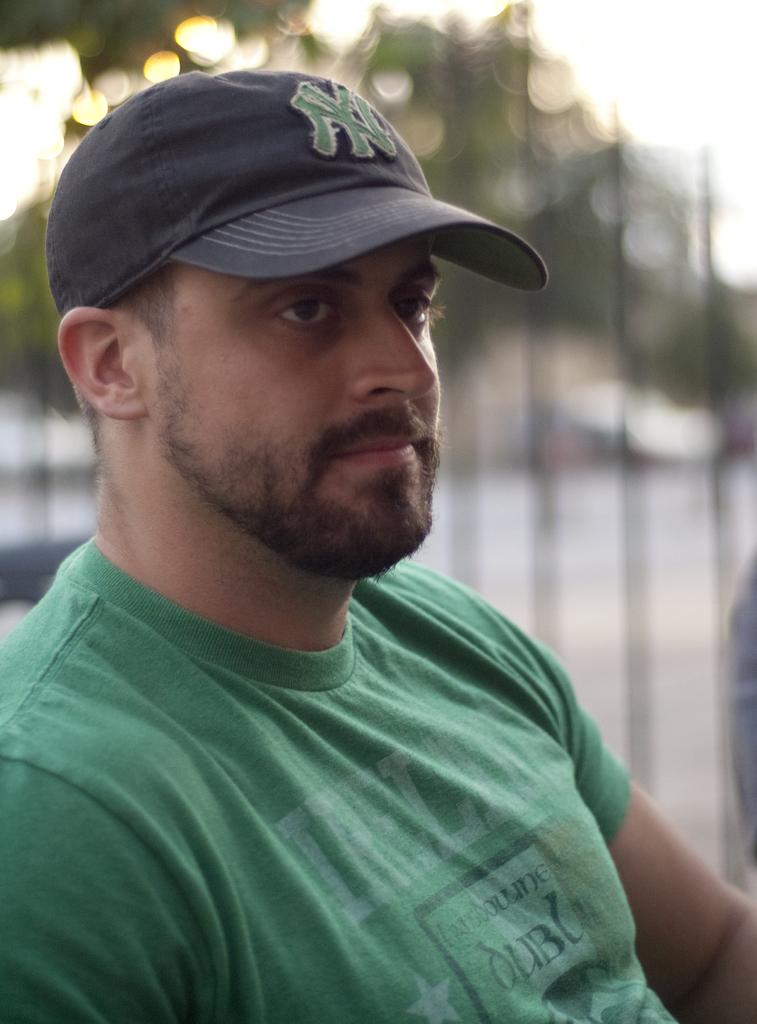Who or what is the main subject in the image? There is a person in the image. What is the person wearing on their upper body? The person is wearing a green t-shirt. What type of headwear is the person wearing? The person is wearing a black hat. Can you describe the background of the image? The background of the image is blurred. What type of learning material can be seen on the station in the image? There is no learning material or station present in the image; it features a person wearing a green t-shirt and black hat with a blurred background. 